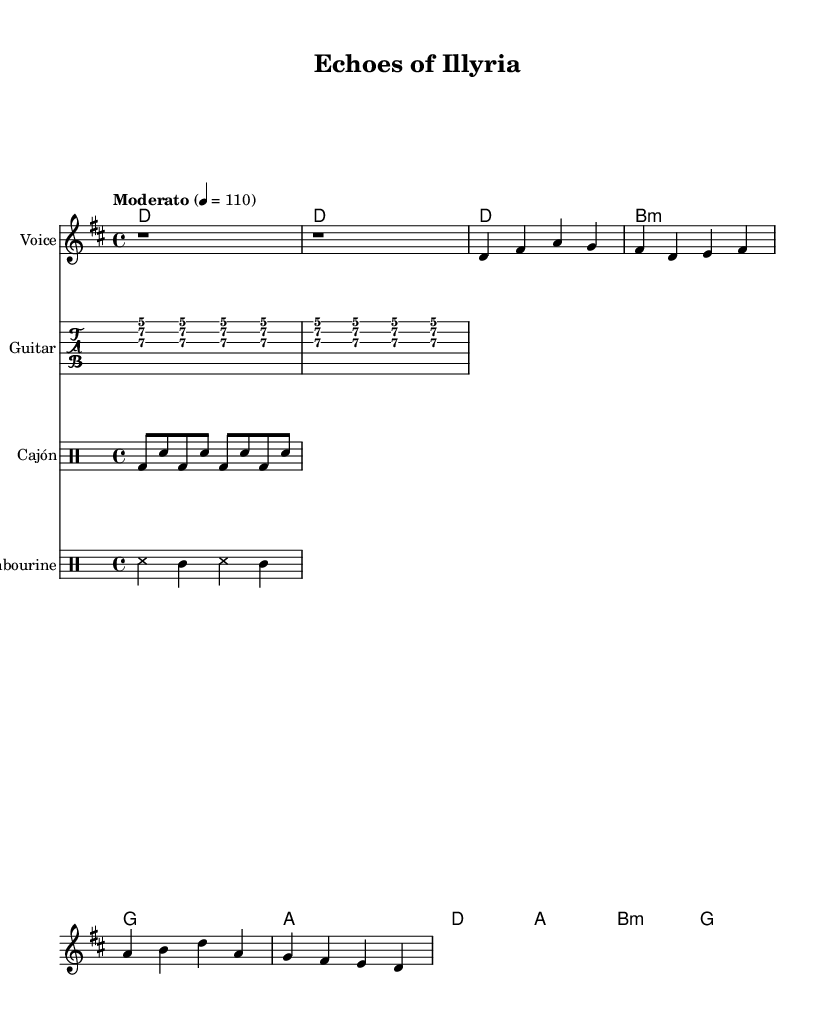What is the key signature of this music? The key signature is D major, which has two sharps (F# and C#). This can be determined by looking at the key indicated in the global variable section.
Answer: D major What is the time signature of this music? The time signature is 4/4, which indicates four beats per measure. This is stated in the global variable section.
Answer: 4/4 What is the tempo marking of this piece? The tempo marking is Moderato, indicated in the global section, and it specifies a moderate speed. The beats per minute is also noted to be 110.
Answer: Moderato How many measures are in the verse section? The verse section has four measures, as denoted by the group of notes that follow the intro section. Each measure corresponds to the melody written for the verse.
Answer: Four measures Which instruments are used in this arrangement? The arrangement includes voice, guitar, cajón, and tambourine, which can be seen by the staff names indicated in each respective section of the score.
Answer: Voice, guitar, cajón, tambourine What is the chord progression in the chorus? The chord progression in the chorus is D, A, B minor, G. This can be identified by looking at the harmonies provided in the relevant section for the chorus part of the song.
Answer: D, A, B minor, G What cultural theme does the song convey? The song conveys themes of Illyrian heritage by referring to ancient lands and eagles’ flight in the lyrics. This theme can be inferred from the lyrical content of the verse and chorus.
Answer: Illyrian heritage 